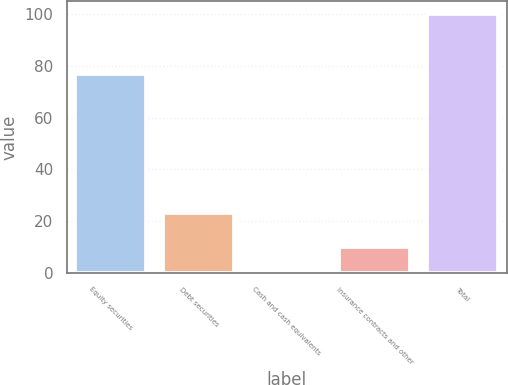Convert chart. <chart><loc_0><loc_0><loc_500><loc_500><bar_chart><fcel>Equity securities<fcel>Debt securities<fcel>Cash and cash equivalents<fcel>Insurance contracts and other<fcel>Total<nl><fcel>77<fcel>23<fcel>0.18<fcel>10.16<fcel>100<nl></chart> 